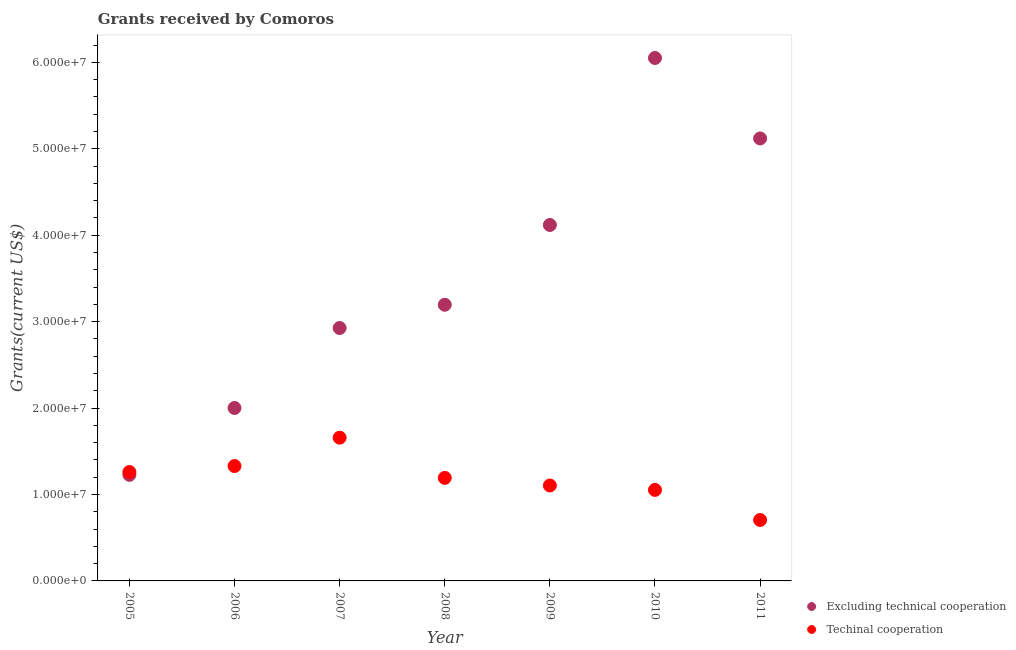Is the number of dotlines equal to the number of legend labels?
Your response must be concise. Yes. What is the amount of grants received(excluding technical cooperation) in 2011?
Offer a very short reply. 5.12e+07. Across all years, what is the maximum amount of grants received(including technical cooperation)?
Your answer should be very brief. 1.66e+07. Across all years, what is the minimum amount of grants received(excluding technical cooperation)?
Your response must be concise. 1.23e+07. What is the total amount of grants received(excluding technical cooperation) in the graph?
Offer a terse response. 2.46e+08. What is the difference between the amount of grants received(excluding technical cooperation) in 2009 and that in 2011?
Provide a short and direct response. -1.00e+07. What is the difference between the amount of grants received(excluding technical cooperation) in 2009 and the amount of grants received(including technical cooperation) in 2005?
Provide a short and direct response. 2.86e+07. What is the average amount of grants received(excluding technical cooperation) per year?
Offer a very short reply. 3.52e+07. In the year 2005, what is the difference between the amount of grants received(including technical cooperation) and amount of grants received(excluding technical cooperation)?
Give a very brief answer. 3.30e+05. In how many years, is the amount of grants received(including technical cooperation) greater than 38000000 US$?
Your response must be concise. 0. What is the ratio of the amount of grants received(including technical cooperation) in 2007 to that in 2008?
Your answer should be compact. 1.39. Is the amount of grants received(including technical cooperation) in 2007 less than that in 2008?
Your answer should be compact. No. What is the difference between the highest and the second highest amount of grants received(including technical cooperation)?
Your answer should be very brief. 3.28e+06. What is the difference between the highest and the lowest amount of grants received(including technical cooperation)?
Your answer should be compact. 9.52e+06. Is the amount of grants received(including technical cooperation) strictly greater than the amount of grants received(excluding technical cooperation) over the years?
Offer a terse response. No. How many dotlines are there?
Provide a succinct answer. 2. Does the graph contain grids?
Offer a very short reply. No. How many legend labels are there?
Ensure brevity in your answer.  2. What is the title of the graph?
Ensure brevity in your answer.  Grants received by Comoros. Does "Commercial bank branches" appear as one of the legend labels in the graph?
Your answer should be very brief. No. What is the label or title of the Y-axis?
Provide a succinct answer. Grants(current US$). What is the Grants(current US$) of Excluding technical cooperation in 2005?
Your answer should be very brief. 1.23e+07. What is the Grants(current US$) in Techinal cooperation in 2005?
Ensure brevity in your answer.  1.26e+07. What is the Grants(current US$) in Excluding technical cooperation in 2006?
Your response must be concise. 2.00e+07. What is the Grants(current US$) in Techinal cooperation in 2006?
Provide a short and direct response. 1.33e+07. What is the Grants(current US$) of Excluding technical cooperation in 2007?
Your answer should be very brief. 2.93e+07. What is the Grants(current US$) in Techinal cooperation in 2007?
Ensure brevity in your answer.  1.66e+07. What is the Grants(current US$) in Excluding technical cooperation in 2008?
Offer a terse response. 3.20e+07. What is the Grants(current US$) of Techinal cooperation in 2008?
Offer a very short reply. 1.19e+07. What is the Grants(current US$) of Excluding technical cooperation in 2009?
Offer a terse response. 4.12e+07. What is the Grants(current US$) in Techinal cooperation in 2009?
Ensure brevity in your answer.  1.10e+07. What is the Grants(current US$) in Excluding technical cooperation in 2010?
Your answer should be compact. 6.05e+07. What is the Grants(current US$) in Techinal cooperation in 2010?
Ensure brevity in your answer.  1.05e+07. What is the Grants(current US$) of Excluding technical cooperation in 2011?
Your answer should be compact. 5.12e+07. What is the Grants(current US$) of Techinal cooperation in 2011?
Make the answer very short. 7.05e+06. Across all years, what is the maximum Grants(current US$) of Excluding technical cooperation?
Your response must be concise. 6.05e+07. Across all years, what is the maximum Grants(current US$) of Techinal cooperation?
Give a very brief answer. 1.66e+07. Across all years, what is the minimum Grants(current US$) of Excluding technical cooperation?
Ensure brevity in your answer.  1.23e+07. Across all years, what is the minimum Grants(current US$) of Techinal cooperation?
Provide a succinct answer. 7.05e+06. What is the total Grants(current US$) of Excluding technical cooperation in the graph?
Keep it short and to the point. 2.46e+08. What is the total Grants(current US$) of Techinal cooperation in the graph?
Ensure brevity in your answer.  8.30e+07. What is the difference between the Grants(current US$) of Excluding technical cooperation in 2005 and that in 2006?
Give a very brief answer. -7.74e+06. What is the difference between the Grants(current US$) of Techinal cooperation in 2005 and that in 2006?
Make the answer very short. -6.90e+05. What is the difference between the Grants(current US$) of Excluding technical cooperation in 2005 and that in 2007?
Ensure brevity in your answer.  -1.70e+07. What is the difference between the Grants(current US$) of Techinal cooperation in 2005 and that in 2007?
Offer a very short reply. -3.97e+06. What is the difference between the Grants(current US$) in Excluding technical cooperation in 2005 and that in 2008?
Make the answer very short. -1.97e+07. What is the difference between the Grants(current US$) in Techinal cooperation in 2005 and that in 2008?
Offer a very short reply. 6.80e+05. What is the difference between the Grants(current US$) in Excluding technical cooperation in 2005 and that in 2009?
Give a very brief answer. -2.89e+07. What is the difference between the Grants(current US$) in Techinal cooperation in 2005 and that in 2009?
Provide a short and direct response. 1.56e+06. What is the difference between the Grants(current US$) in Excluding technical cooperation in 2005 and that in 2010?
Your response must be concise. -4.82e+07. What is the difference between the Grants(current US$) in Techinal cooperation in 2005 and that in 2010?
Give a very brief answer. 2.07e+06. What is the difference between the Grants(current US$) of Excluding technical cooperation in 2005 and that in 2011?
Give a very brief answer. -3.89e+07. What is the difference between the Grants(current US$) of Techinal cooperation in 2005 and that in 2011?
Your answer should be compact. 5.55e+06. What is the difference between the Grants(current US$) in Excluding technical cooperation in 2006 and that in 2007?
Your response must be concise. -9.25e+06. What is the difference between the Grants(current US$) of Techinal cooperation in 2006 and that in 2007?
Make the answer very short. -3.28e+06. What is the difference between the Grants(current US$) of Excluding technical cooperation in 2006 and that in 2008?
Give a very brief answer. -1.19e+07. What is the difference between the Grants(current US$) of Techinal cooperation in 2006 and that in 2008?
Offer a very short reply. 1.37e+06. What is the difference between the Grants(current US$) of Excluding technical cooperation in 2006 and that in 2009?
Make the answer very short. -2.12e+07. What is the difference between the Grants(current US$) of Techinal cooperation in 2006 and that in 2009?
Offer a very short reply. 2.25e+06. What is the difference between the Grants(current US$) in Excluding technical cooperation in 2006 and that in 2010?
Keep it short and to the point. -4.05e+07. What is the difference between the Grants(current US$) of Techinal cooperation in 2006 and that in 2010?
Your response must be concise. 2.76e+06. What is the difference between the Grants(current US$) in Excluding technical cooperation in 2006 and that in 2011?
Ensure brevity in your answer.  -3.12e+07. What is the difference between the Grants(current US$) of Techinal cooperation in 2006 and that in 2011?
Give a very brief answer. 6.24e+06. What is the difference between the Grants(current US$) of Excluding technical cooperation in 2007 and that in 2008?
Ensure brevity in your answer.  -2.69e+06. What is the difference between the Grants(current US$) of Techinal cooperation in 2007 and that in 2008?
Give a very brief answer. 4.65e+06. What is the difference between the Grants(current US$) in Excluding technical cooperation in 2007 and that in 2009?
Your response must be concise. -1.19e+07. What is the difference between the Grants(current US$) in Techinal cooperation in 2007 and that in 2009?
Ensure brevity in your answer.  5.53e+06. What is the difference between the Grants(current US$) in Excluding technical cooperation in 2007 and that in 2010?
Make the answer very short. -3.12e+07. What is the difference between the Grants(current US$) of Techinal cooperation in 2007 and that in 2010?
Ensure brevity in your answer.  6.04e+06. What is the difference between the Grants(current US$) in Excluding technical cooperation in 2007 and that in 2011?
Your answer should be very brief. -2.19e+07. What is the difference between the Grants(current US$) of Techinal cooperation in 2007 and that in 2011?
Keep it short and to the point. 9.52e+06. What is the difference between the Grants(current US$) of Excluding technical cooperation in 2008 and that in 2009?
Your answer should be very brief. -9.23e+06. What is the difference between the Grants(current US$) in Techinal cooperation in 2008 and that in 2009?
Ensure brevity in your answer.  8.80e+05. What is the difference between the Grants(current US$) of Excluding technical cooperation in 2008 and that in 2010?
Your response must be concise. -2.86e+07. What is the difference between the Grants(current US$) of Techinal cooperation in 2008 and that in 2010?
Keep it short and to the point. 1.39e+06. What is the difference between the Grants(current US$) in Excluding technical cooperation in 2008 and that in 2011?
Ensure brevity in your answer.  -1.92e+07. What is the difference between the Grants(current US$) of Techinal cooperation in 2008 and that in 2011?
Your answer should be compact. 4.87e+06. What is the difference between the Grants(current US$) in Excluding technical cooperation in 2009 and that in 2010?
Your answer should be very brief. -1.93e+07. What is the difference between the Grants(current US$) of Techinal cooperation in 2009 and that in 2010?
Offer a very short reply. 5.10e+05. What is the difference between the Grants(current US$) of Excluding technical cooperation in 2009 and that in 2011?
Give a very brief answer. -1.00e+07. What is the difference between the Grants(current US$) in Techinal cooperation in 2009 and that in 2011?
Ensure brevity in your answer.  3.99e+06. What is the difference between the Grants(current US$) of Excluding technical cooperation in 2010 and that in 2011?
Your response must be concise. 9.31e+06. What is the difference between the Grants(current US$) in Techinal cooperation in 2010 and that in 2011?
Give a very brief answer. 3.48e+06. What is the difference between the Grants(current US$) of Excluding technical cooperation in 2005 and the Grants(current US$) of Techinal cooperation in 2006?
Provide a succinct answer. -1.02e+06. What is the difference between the Grants(current US$) of Excluding technical cooperation in 2005 and the Grants(current US$) of Techinal cooperation in 2007?
Offer a terse response. -4.30e+06. What is the difference between the Grants(current US$) in Excluding technical cooperation in 2005 and the Grants(current US$) in Techinal cooperation in 2008?
Your response must be concise. 3.50e+05. What is the difference between the Grants(current US$) in Excluding technical cooperation in 2005 and the Grants(current US$) in Techinal cooperation in 2009?
Offer a very short reply. 1.23e+06. What is the difference between the Grants(current US$) in Excluding technical cooperation in 2005 and the Grants(current US$) in Techinal cooperation in 2010?
Provide a short and direct response. 1.74e+06. What is the difference between the Grants(current US$) in Excluding technical cooperation in 2005 and the Grants(current US$) in Techinal cooperation in 2011?
Your answer should be very brief. 5.22e+06. What is the difference between the Grants(current US$) in Excluding technical cooperation in 2006 and the Grants(current US$) in Techinal cooperation in 2007?
Your answer should be very brief. 3.44e+06. What is the difference between the Grants(current US$) of Excluding technical cooperation in 2006 and the Grants(current US$) of Techinal cooperation in 2008?
Offer a terse response. 8.09e+06. What is the difference between the Grants(current US$) in Excluding technical cooperation in 2006 and the Grants(current US$) in Techinal cooperation in 2009?
Your answer should be very brief. 8.97e+06. What is the difference between the Grants(current US$) in Excluding technical cooperation in 2006 and the Grants(current US$) in Techinal cooperation in 2010?
Your response must be concise. 9.48e+06. What is the difference between the Grants(current US$) of Excluding technical cooperation in 2006 and the Grants(current US$) of Techinal cooperation in 2011?
Ensure brevity in your answer.  1.30e+07. What is the difference between the Grants(current US$) in Excluding technical cooperation in 2007 and the Grants(current US$) in Techinal cooperation in 2008?
Your answer should be compact. 1.73e+07. What is the difference between the Grants(current US$) of Excluding technical cooperation in 2007 and the Grants(current US$) of Techinal cooperation in 2009?
Keep it short and to the point. 1.82e+07. What is the difference between the Grants(current US$) in Excluding technical cooperation in 2007 and the Grants(current US$) in Techinal cooperation in 2010?
Your answer should be very brief. 1.87e+07. What is the difference between the Grants(current US$) of Excluding technical cooperation in 2007 and the Grants(current US$) of Techinal cooperation in 2011?
Your answer should be very brief. 2.22e+07. What is the difference between the Grants(current US$) in Excluding technical cooperation in 2008 and the Grants(current US$) in Techinal cooperation in 2009?
Offer a very short reply. 2.09e+07. What is the difference between the Grants(current US$) of Excluding technical cooperation in 2008 and the Grants(current US$) of Techinal cooperation in 2010?
Make the answer very short. 2.14e+07. What is the difference between the Grants(current US$) of Excluding technical cooperation in 2008 and the Grants(current US$) of Techinal cooperation in 2011?
Provide a succinct answer. 2.49e+07. What is the difference between the Grants(current US$) of Excluding technical cooperation in 2009 and the Grants(current US$) of Techinal cooperation in 2010?
Provide a succinct answer. 3.06e+07. What is the difference between the Grants(current US$) in Excluding technical cooperation in 2009 and the Grants(current US$) in Techinal cooperation in 2011?
Your response must be concise. 3.41e+07. What is the difference between the Grants(current US$) in Excluding technical cooperation in 2010 and the Grants(current US$) in Techinal cooperation in 2011?
Your response must be concise. 5.34e+07. What is the average Grants(current US$) of Excluding technical cooperation per year?
Your response must be concise. 3.52e+07. What is the average Grants(current US$) in Techinal cooperation per year?
Keep it short and to the point. 1.19e+07. In the year 2005, what is the difference between the Grants(current US$) of Excluding technical cooperation and Grants(current US$) of Techinal cooperation?
Offer a very short reply. -3.30e+05. In the year 2006, what is the difference between the Grants(current US$) in Excluding technical cooperation and Grants(current US$) in Techinal cooperation?
Provide a succinct answer. 6.72e+06. In the year 2007, what is the difference between the Grants(current US$) of Excluding technical cooperation and Grants(current US$) of Techinal cooperation?
Your response must be concise. 1.27e+07. In the year 2008, what is the difference between the Grants(current US$) of Excluding technical cooperation and Grants(current US$) of Techinal cooperation?
Offer a very short reply. 2.00e+07. In the year 2009, what is the difference between the Grants(current US$) of Excluding technical cooperation and Grants(current US$) of Techinal cooperation?
Ensure brevity in your answer.  3.01e+07. In the year 2010, what is the difference between the Grants(current US$) in Excluding technical cooperation and Grants(current US$) in Techinal cooperation?
Make the answer very short. 5.00e+07. In the year 2011, what is the difference between the Grants(current US$) in Excluding technical cooperation and Grants(current US$) in Techinal cooperation?
Offer a terse response. 4.41e+07. What is the ratio of the Grants(current US$) in Excluding technical cooperation in 2005 to that in 2006?
Offer a very short reply. 0.61. What is the ratio of the Grants(current US$) of Techinal cooperation in 2005 to that in 2006?
Provide a succinct answer. 0.95. What is the ratio of the Grants(current US$) in Excluding technical cooperation in 2005 to that in 2007?
Provide a short and direct response. 0.42. What is the ratio of the Grants(current US$) in Techinal cooperation in 2005 to that in 2007?
Your response must be concise. 0.76. What is the ratio of the Grants(current US$) in Excluding technical cooperation in 2005 to that in 2008?
Offer a very short reply. 0.38. What is the ratio of the Grants(current US$) in Techinal cooperation in 2005 to that in 2008?
Give a very brief answer. 1.06. What is the ratio of the Grants(current US$) in Excluding technical cooperation in 2005 to that in 2009?
Your answer should be very brief. 0.3. What is the ratio of the Grants(current US$) of Techinal cooperation in 2005 to that in 2009?
Make the answer very short. 1.14. What is the ratio of the Grants(current US$) in Excluding technical cooperation in 2005 to that in 2010?
Your answer should be very brief. 0.2. What is the ratio of the Grants(current US$) in Techinal cooperation in 2005 to that in 2010?
Offer a terse response. 1.2. What is the ratio of the Grants(current US$) in Excluding technical cooperation in 2005 to that in 2011?
Your response must be concise. 0.24. What is the ratio of the Grants(current US$) in Techinal cooperation in 2005 to that in 2011?
Give a very brief answer. 1.79. What is the ratio of the Grants(current US$) of Excluding technical cooperation in 2006 to that in 2007?
Your answer should be very brief. 0.68. What is the ratio of the Grants(current US$) of Techinal cooperation in 2006 to that in 2007?
Make the answer very short. 0.8. What is the ratio of the Grants(current US$) in Excluding technical cooperation in 2006 to that in 2008?
Offer a terse response. 0.63. What is the ratio of the Grants(current US$) in Techinal cooperation in 2006 to that in 2008?
Your answer should be compact. 1.11. What is the ratio of the Grants(current US$) in Excluding technical cooperation in 2006 to that in 2009?
Your answer should be very brief. 0.49. What is the ratio of the Grants(current US$) of Techinal cooperation in 2006 to that in 2009?
Ensure brevity in your answer.  1.2. What is the ratio of the Grants(current US$) in Excluding technical cooperation in 2006 to that in 2010?
Offer a terse response. 0.33. What is the ratio of the Grants(current US$) of Techinal cooperation in 2006 to that in 2010?
Your answer should be compact. 1.26. What is the ratio of the Grants(current US$) of Excluding technical cooperation in 2006 to that in 2011?
Provide a short and direct response. 0.39. What is the ratio of the Grants(current US$) of Techinal cooperation in 2006 to that in 2011?
Your answer should be very brief. 1.89. What is the ratio of the Grants(current US$) in Excluding technical cooperation in 2007 to that in 2008?
Your response must be concise. 0.92. What is the ratio of the Grants(current US$) of Techinal cooperation in 2007 to that in 2008?
Provide a succinct answer. 1.39. What is the ratio of the Grants(current US$) in Excluding technical cooperation in 2007 to that in 2009?
Provide a short and direct response. 0.71. What is the ratio of the Grants(current US$) of Techinal cooperation in 2007 to that in 2009?
Offer a terse response. 1.5. What is the ratio of the Grants(current US$) in Excluding technical cooperation in 2007 to that in 2010?
Make the answer very short. 0.48. What is the ratio of the Grants(current US$) in Techinal cooperation in 2007 to that in 2010?
Give a very brief answer. 1.57. What is the ratio of the Grants(current US$) of Excluding technical cooperation in 2007 to that in 2011?
Your answer should be very brief. 0.57. What is the ratio of the Grants(current US$) in Techinal cooperation in 2007 to that in 2011?
Your answer should be compact. 2.35. What is the ratio of the Grants(current US$) in Excluding technical cooperation in 2008 to that in 2009?
Provide a short and direct response. 0.78. What is the ratio of the Grants(current US$) of Techinal cooperation in 2008 to that in 2009?
Your response must be concise. 1.08. What is the ratio of the Grants(current US$) in Excluding technical cooperation in 2008 to that in 2010?
Your answer should be compact. 0.53. What is the ratio of the Grants(current US$) of Techinal cooperation in 2008 to that in 2010?
Provide a succinct answer. 1.13. What is the ratio of the Grants(current US$) of Excluding technical cooperation in 2008 to that in 2011?
Offer a very short reply. 0.62. What is the ratio of the Grants(current US$) of Techinal cooperation in 2008 to that in 2011?
Your response must be concise. 1.69. What is the ratio of the Grants(current US$) in Excluding technical cooperation in 2009 to that in 2010?
Offer a very short reply. 0.68. What is the ratio of the Grants(current US$) of Techinal cooperation in 2009 to that in 2010?
Ensure brevity in your answer.  1.05. What is the ratio of the Grants(current US$) in Excluding technical cooperation in 2009 to that in 2011?
Ensure brevity in your answer.  0.8. What is the ratio of the Grants(current US$) of Techinal cooperation in 2009 to that in 2011?
Your response must be concise. 1.57. What is the ratio of the Grants(current US$) in Excluding technical cooperation in 2010 to that in 2011?
Your response must be concise. 1.18. What is the ratio of the Grants(current US$) in Techinal cooperation in 2010 to that in 2011?
Make the answer very short. 1.49. What is the difference between the highest and the second highest Grants(current US$) of Excluding technical cooperation?
Your answer should be compact. 9.31e+06. What is the difference between the highest and the second highest Grants(current US$) in Techinal cooperation?
Your answer should be compact. 3.28e+06. What is the difference between the highest and the lowest Grants(current US$) in Excluding technical cooperation?
Provide a succinct answer. 4.82e+07. What is the difference between the highest and the lowest Grants(current US$) in Techinal cooperation?
Offer a very short reply. 9.52e+06. 